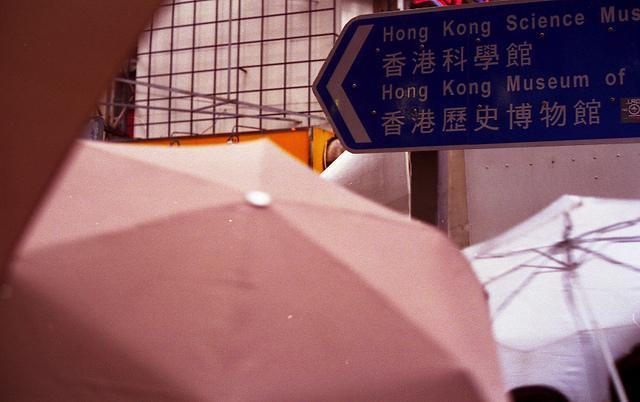How many can be seen?
Give a very brief answer. 2. How many umbrellas are there?
Give a very brief answer. 2. How many vases are broken?
Give a very brief answer. 0. 